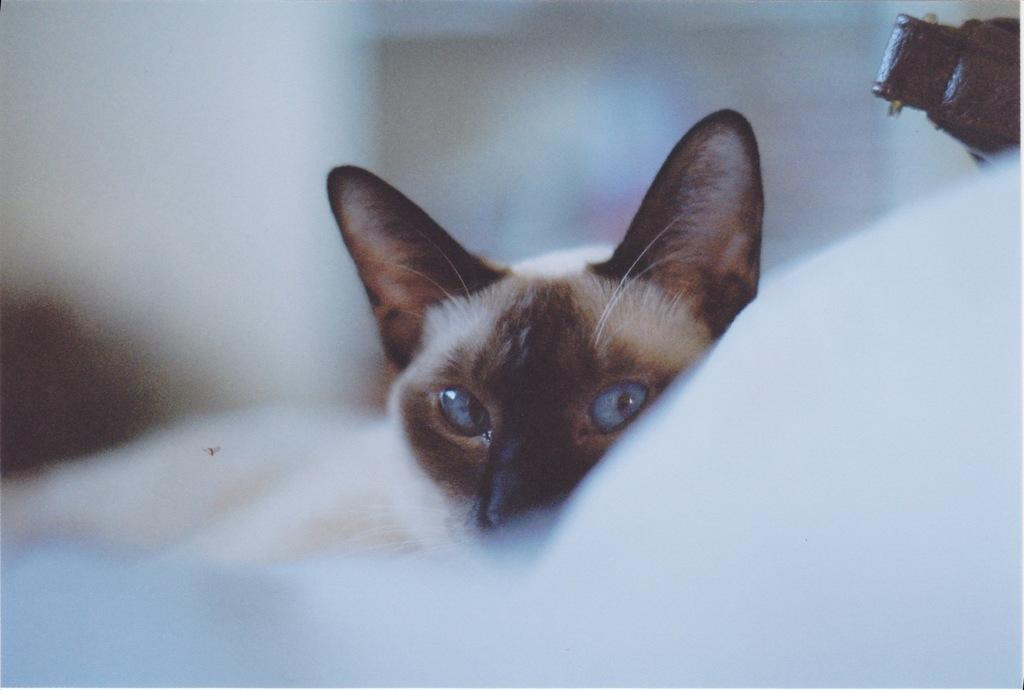What type of animal is present in the image? There is a cat in the image. Can you describe the background of the image? The background of the image is blurred. Is there a chance of the cat winning a water-bubble contest in the image? There is no water-bubble contest or any reference to water or bubbles in the image, so it is not possible to determine if the cat has a chance of winning such a contest. 